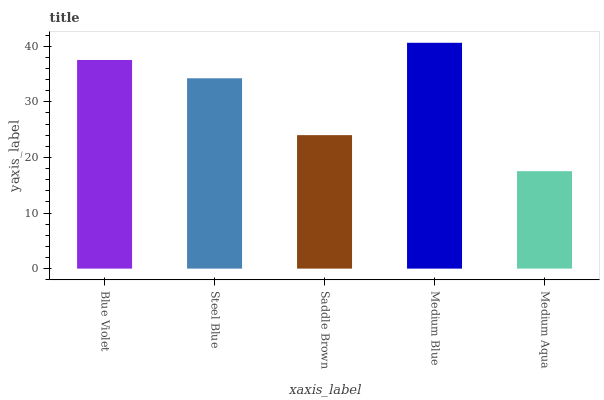Is Medium Aqua the minimum?
Answer yes or no. Yes. Is Medium Blue the maximum?
Answer yes or no. Yes. Is Steel Blue the minimum?
Answer yes or no. No. Is Steel Blue the maximum?
Answer yes or no. No. Is Blue Violet greater than Steel Blue?
Answer yes or no. Yes. Is Steel Blue less than Blue Violet?
Answer yes or no. Yes. Is Steel Blue greater than Blue Violet?
Answer yes or no. No. Is Blue Violet less than Steel Blue?
Answer yes or no. No. Is Steel Blue the high median?
Answer yes or no. Yes. Is Steel Blue the low median?
Answer yes or no. Yes. Is Medium Aqua the high median?
Answer yes or no. No. Is Saddle Brown the low median?
Answer yes or no. No. 